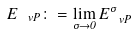<formula> <loc_0><loc_0><loc_500><loc_500>E _ { \ v P } \colon = \lim _ { \sigma \to 0 } E _ { \ v P } ^ { \sigma }</formula> 